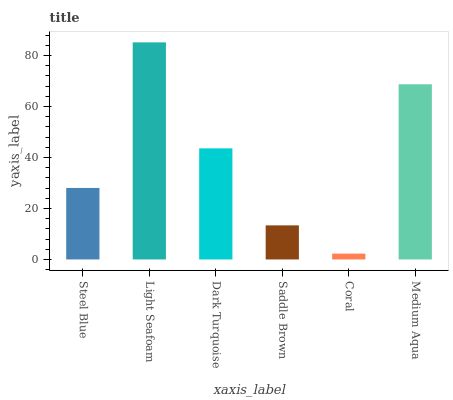Is Dark Turquoise the minimum?
Answer yes or no. No. Is Dark Turquoise the maximum?
Answer yes or no. No. Is Light Seafoam greater than Dark Turquoise?
Answer yes or no. Yes. Is Dark Turquoise less than Light Seafoam?
Answer yes or no. Yes. Is Dark Turquoise greater than Light Seafoam?
Answer yes or no. No. Is Light Seafoam less than Dark Turquoise?
Answer yes or no. No. Is Dark Turquoise the high median?
Answer yes or no. Yes. Is Steel Blue the low median?
Answer yes or no. Yes. Is Coral the high median?
Answer yes or no. No. Is Dark Turquoise the low median?
Answer yes or no. No. 